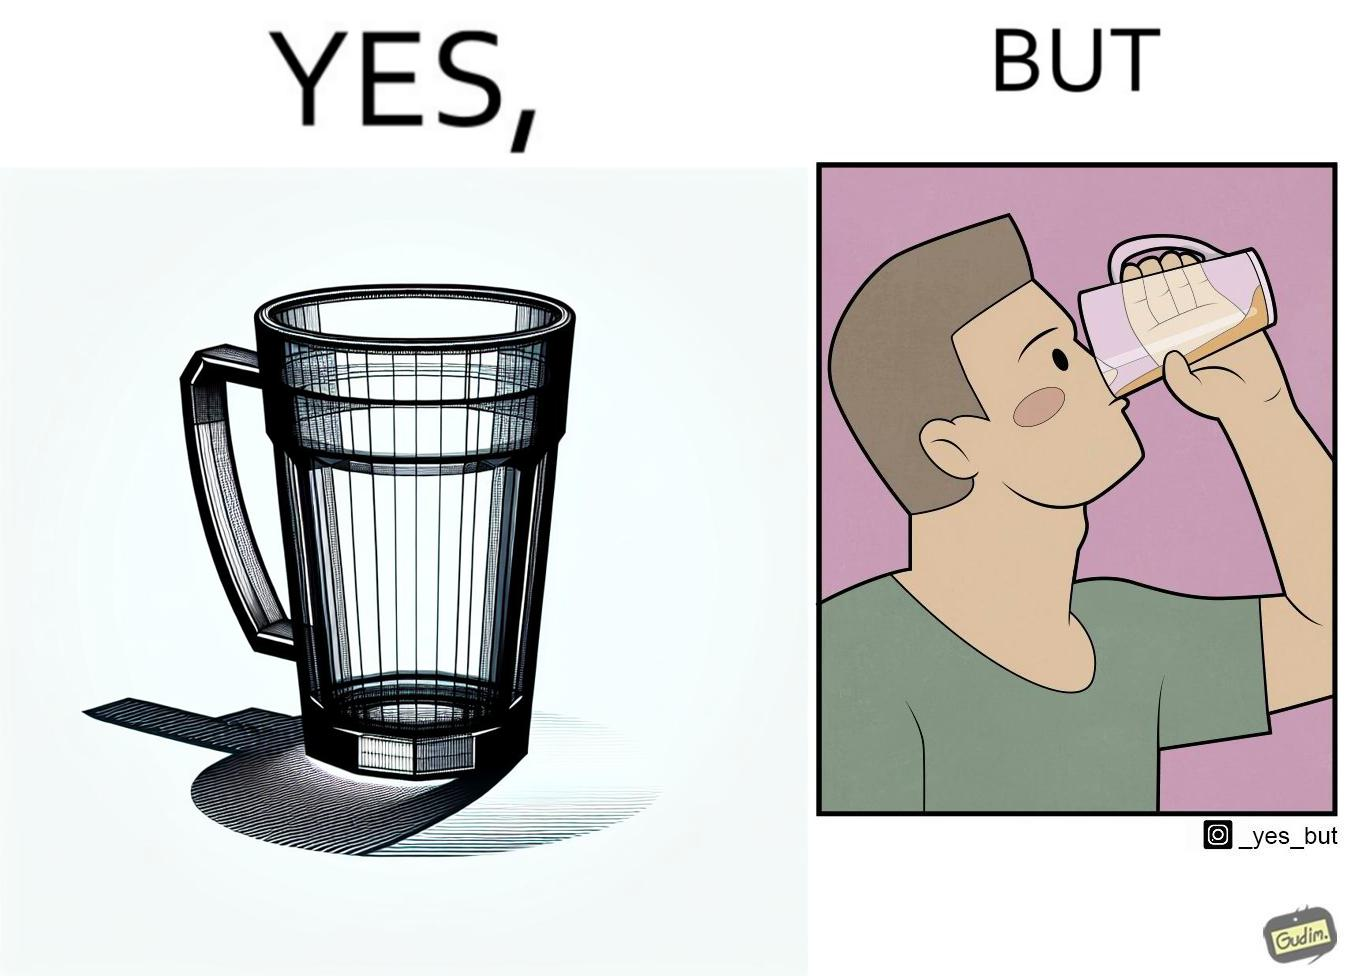Is this image satirical or non-satirical? Yes, this image is satirical. 